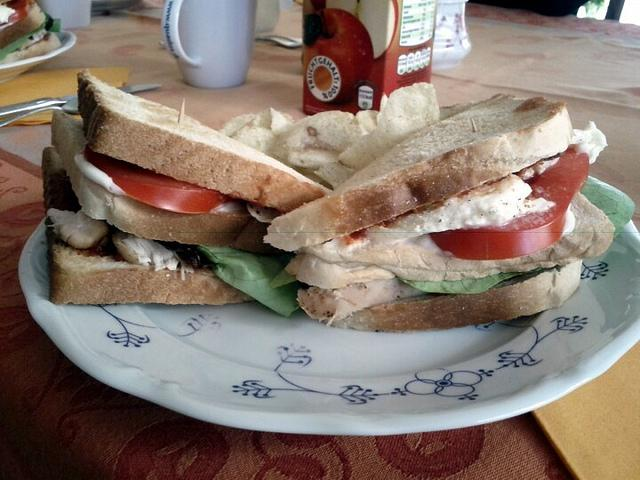What vegetable was used to make the side dish for this sandwich lunch? Please explain your reasoning. potato. The side dish is potato chips which are made of potatoes. 